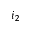Convert formula to latex. <formula><loc_0><loc_0><loc_500><loc_500>i _ { 2 }</formula> 